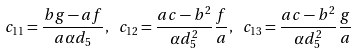Convert formula to latex. <formula><loc_0><loc_0><loc_500><loc_500>c _ { 1 1 } = \frac { b g - a f } { a \alpha d _ { 5 } } , \ c _ { 1 2 } = \frac { a c - b ^ { 2 } } { \alpha d _ { 5 } ^ { 2 } } \frac { f } { a } , \ c _ { 1 3 } = \frac { a c - b ^ { 2 } } { \alpha d _ { 5 } ^ { 2 } } \frac { g } { a }</formula> 